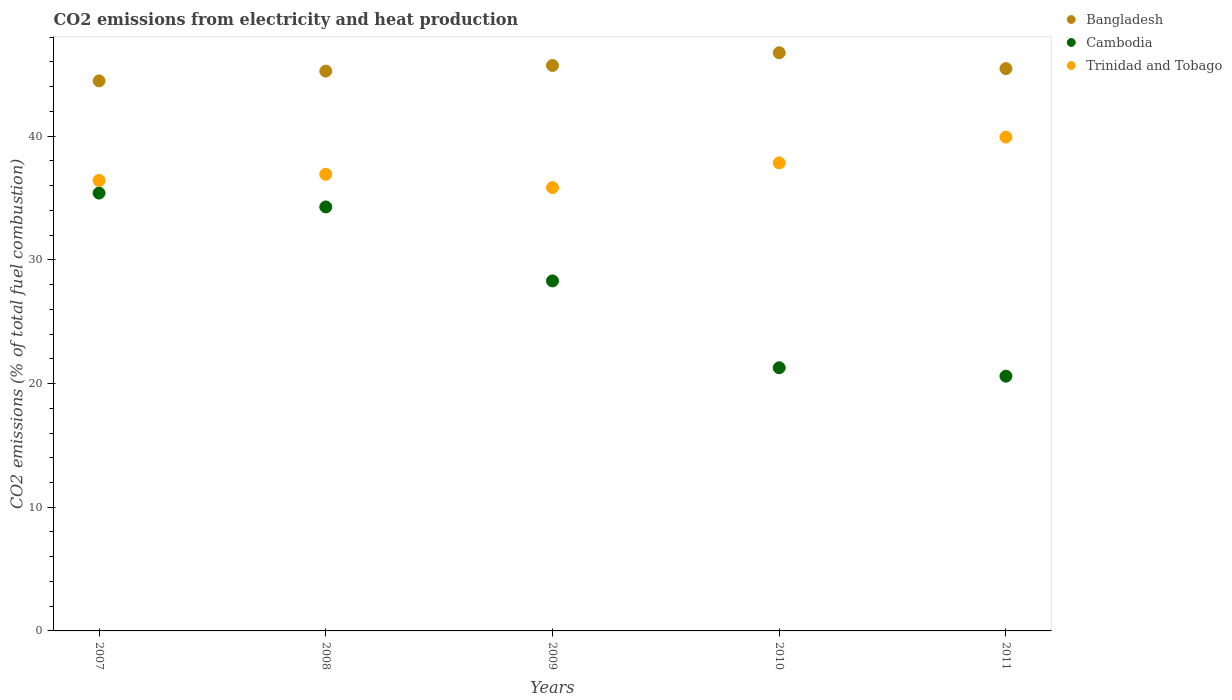What is the amount of CO2 emitted in Bangladesh in 2008?
Make the answer very short. 45.26. Across all years, what is the maximum amount of CO2 emitted in Bangladesh?
Provide a short and direct response. 46.74. Across all years, what is the minimum amount of CO2 emitted in Bangladesh?
Keep it short and to the point. 44.47. In which year was the amount of CO2 emitted in Bangladesh maximum?
Your answer should be very brief. 2010. In which year was the amount of CO2 emitted in Cambodia minimum?
Your answer should be compact. 2011. What is the total amount of CO2 emitted in Cambodia in the graph?
Your response must be concise. 139.84. What is the difference between the amount of CO2 emitted in Trinidad and Tobago in 2008 and that in 2011?
Your response must be concise. -3.01. What is the difference between the amount of CO2 emitted in Trinidad and Tobago in 2008 and the amount of CO2 emitted in Cambodia in 2009?
Ensure brevity in your answer.  8.62. What is the average amount of CO2 emitted in Trinidad and Tobago per year?
Keep it short and to the point. 37.39. In the year 2009, what is the difference between the amount of CO2 emitted in Bangladesh and amount of CO2 emitted in Trinidad and Tobago?
Provide a succinct answer. 9.87. In how many years, is the amount of CO2 emitted in Trinidad and Tobago greater than 12 %?
Your answer should be very brief. 5. What is the ratio of the amount of CO2 emitted in Bangladesh in 2008 to that in 2010?
Offer a terse response. 0.97. Is the difference between the amount of CO2 emitted in Bangladesh in 2007 and 2010 greater than the difference between the amount of CO2 emitted in Trinidad and Tobago in 2007 and 2010?
Make the answer very short. No. What is the difference between the highest and the second highest amount of CO2 emitted in Cambodia?
Offer a terse response. 1.12. What is the difference between the highest and the lowest amount of CO2 emitted in Cambodia?
Offer a terse response. 14.8. Is the sum of the amount of CO2 emitted in Trinidad and Tobago in 2008 and 2010 greater than the maximum amount of CO2 emitted in Bangladesh across all years?
Your response must be concise. Yes. Is the amount of CO2 emitted in Cambodia strictly greater than the amount of CO2 emitted in Bangladesh over the years?
Make the answer very short. No. Is the amount of CO2 emitted in Trinidad and Tobago strictly less than the amount of CO2 emitted in Cambodia over the years?
Make the answer very short. No. How many dotlines are there?
Your answer should be compact. 3. How many years are there in the graph?
Offer a very short reply. 5. Are the values on the major ticks of Y-axis written in scientific E-notation?
Give a very brief answer. No. Does the graph contain grids?
Ensure brevity in your answer.  No. Where does the legend appear in the graph?
Your response must be concise. Top right. What is the title of the graph?
Keep it short and to the point. CO2 emissions from electricity and heat production. Does "Seychelles" appear as one of the legend labels in the graph?
Keep it short and to the point. No. What is the label or title of the X-axis?
Your answer should be compact. Years. What is the label or title of the Y-axis?
Make the answer very short. CO2 emissions (% of total fuel combustion). What is the CO2 emissions (% of total fuel combustion) in Bangladesh in 2007?
Your answer should be very brief. 44.47. What is the CO2 emissions (% of total fuel combustion) of Cambodia in 2007?
Your answer should be very brief. 35.4. What is the CO2 emissions (% of total fuel combustion) of Trinidad and Tobago in 2007?
Provide a succinct answer. 36.42. What is the CO2 emissions (% of total fuel combustion) of Bangladesh in 2008?
Offer a very short reply. 45.26. What is the CO2 emissions (% of total fuel combustion) in Cambodia in 2008?
Make the answer very short. 34.28. What is the CO2 emissions (% of total fuel combustion) in Trinidad and Tobago in 2008?
Your response must be concise. 36.92. What is the CO2 emissions (% of total fuel combustion) of Bangladesh in 2009?
Provide a succinct answer. 45.71. What is the CO2 emissions (% of total fuel combustion) in Cambodia in 2009?
Your response must be concise. 28.3. What is the CO2 emissions (% of total fuel combustion) of Trinidad and Tobago in 2009?
Your response must be concise. 35.84. What is the CO2 emissions (% of total fuel combustion) in Bangladesh in 2010?
Your answer should be very brief. 46.74. What is the CO2 emissions (% of total fuel combustion) of Cambodia in 2010?
Ensure brevity in your answer.  21.28. What is the CO2 emissions (% of total fuel combustion) of Trinidad and Tobago in 2010?
Your response must be concise. 37.84. What is the CO2 emissions (% of total fuel combustion) in Bangladesh in 2011?
Offer a terse response. 45.46. What is the CO2 emissions (% of total fuel combustion) in Cambodia in 2011?
Provide a succinct answer. 20.6. What is the CO2 emissions (% of total fuel combustion) of Trinidad and Tobago in 2011?
Ensure brevity in your answer.  39.93. Across all years, what is the maximum CO2 emissions (% of total fuel combustion) of Bangladesh?
Make the answer very short. 46.74. Across all years, what is the maximum CO2 emissions (% of total fuel combustion) in Cambodia?
Offer a very short reply. 35.4. Across all years, what is the maximum CO2 emissions (% of total fuel combustion) of Trinidad and Tobago?
Your response must be concise. 39.93. Across all years, what is the minimum CO2 emissions (% of total fuel combustion) of Bangladesh?
Provide a succinct answer. 44.47. Across all years, what is the minimum CO2 emissions (% of total fuel combustion) in Cambodia?
Keep it short and to the point. 20.6. Across all years, what is the minimum CO2 emissions (% of total fuel combustion) of Trinidad and Tobago?
Keep it short and to the point. 35.84. What is the total CO2 emissions (% of total fuel combustion) of Bangladesh in the graph?
Make the answer very short. 227.65. What is the total CO2 emissions (% of total fuel combustion) of Cambodia in the graph?
Ensure brevity in your answer.  139.84. What is the total CO2 emissions (% of total fuel combustion) in Trinidad and Tobago in the graph?
Ensure brevity in your answer.  186.95. What is the difference between the CO2 emissions (% of total fuel combustion) of Bangladesh in 2007 and that in 2008?
Provide a short and direct response. -0.79. What is the difference between the CO2 emissions (% of total fuel combustion) of Cambodia in 2007 and that in 2008?
Your response must be concise. 1.12. What is the difference between the CO2 emissions (% of total fuel combustion) of Trinidad and Tobago in 2007 and that in 2008?
Keep it short and to the point. -0.5. What is the difference between the CO2 emissions (% of total fuel combustion) of Bangladesh in 2007 and that in 2009?
Your answer should be very brief. -1.24. What is the difference between the CO2 emissions (% of total fuel combustion) of Cambodia in 2007 and that in 2009?
Offer a terse response. 7.1. What is the difference between the CO2 emissions (% of total fuel combustion) in Trinidad and Tobago in 2007 and that in 2009?
Ensure brevity in your answer.  0.58. What is the difference between the CO2 emissions (% of total fuel combustion) in Bangladesh in 2007 and that in 2010?
Your response must be concise. -2.27. What is the difference between the CO2 emissions (% of total fuel combustion) in Cambodia in 2007 and that in 2010?
Your answer should be very brief. 14.12. What is the difference between the CO2 emissions (% of total fuel combustion) of Trinidad and Tobago in 2007 and that in 2010?
Provide a succinct answer. -1.42. What is the difference between the CO2 emissions (% of total fuel combustion) in Bangladesh in 2007 and that in 2011?
Provide a succinct answer. -0.99. What is the difference between the CO2 emissions (% of total fuel combustion) in Cambodia in 2007 and that in 2011?
Your answer should be very brief. 14.8. What is the difference between the CO2 emissions (% of total fuel combustion) of Trinidad and Tobago in 2007 and that in 2011?
Provide a succinct answer. -3.51. What is the difference between the CO2 emissions (% of total fuel combustion) of Bangladesh in 2008 and that in 2009?
Give a very brief answer. -0.46. What is the difference between the CO2 emissions (% of total fuel combustion) in Cambodia in 2008 and that in 2009?
Give a very brief answer. 5.98. What is the difference between the CO2 emissions (% of total fuel combustion) of Trinidad and Tobago in 2008 and that in 2009?
Your response must be concise. 1.07. What is the difference between the CO2 emissions (% of total fuel combustion) of Bangladesh in 2008 and that in 2010?
Provide a succinct answer. -1.48. What is the difference between the CO2 emissions (% of total fuel combustion) of Cambodia in 2008 and that in 2010?
Offer a terse response. 13. What is the difference between the CO2 emissions (% of total fuel combustion) of Trinidad and Tobago in 2008 and that in 2010?
Your answer should be very brief. -0.92. What is the difference between the CO2 emissions (% of total fuel combustion) in Bangladesh in 2008 and that in 2011?
Give a very brief answer. -0.2. What is the difference between the CO2 emissions (% of total fuel combustion) of Cambodia in 2008 and that in 2011?
Provide a short and direct response. 13.68. What is the difference between the CO2 emissions (% of total fuel combustion) of Trinidad and Tobago in 2008 and that in 2011?
Offer a terse response. -3.01. What is the difference between the CO2 emissions (% of total fuel combustion) of Bangladesh in 2009 and that in 2010?
Offer a terse response. -1.03. What is the difference between the CO2 emissions (% of total fuel combustion) of Cambodia in 2009 and that in 2010?
Your response must be concise. 7.02. What is the difference between the CO2 emissions (% of total fuel combustion) of Trinidad and Tobago in 2009 and that in 2010?
Ensure brevity in your answer.  -2. What is the difference between the CO2 emissions (% of total fuel combustion) of Bangladesh in 2009 and that in 2011?
Offer a terse response. 0.25. What is the difference between the CO2 emissions (% of total fuel combustion) of Cambodia in 2009 and that in 2011?
Make the answer very short. 7.7. What is the difference between the CO2 emissions (% of total fuel combustion) of Trinidad and Tobago in 2009 and that in 2011?
Your response must be concise. -4.08. What is the difference between the CO2 emissions (% of total fuel combustion) in Bangladesh in 2010 and that in 2011?
Provide a succinct answer. 1.28. What is the difference between the CO2 emissions (% of total fuel combustion) of Cambodia in 2010 and that in 2011?
Your answer should be very brief. 0.68. What is the difference between the CO2 emissions (% of total fuel combustion) of Trinidad and Tobago in 2010 and that in 2011?
Your response must be concise. -2.09. What is the difference between the CO2 emissions (% of total fuel combustion) in Bangladesh in 2007 and the CO2 emissions (% of total fuel combustion) in Cambodia in 2008?
Make the answer very short. 10.19. What is the difference between the CO2 emissions (% of total fuel combustion) of Bangladesh in 2007 and the CO2 emissions (% of total fuel combustion) of Trinidad and Tobago in 2008?
Your answer should be compact. 7.55. What is the difference between the CO2 emissions (% of total fuel combustion) in Cambodia in 2007 and the CO2 emissions (% of total fuel combustion) in Trinidad and Tobago in 2008?
Give a very brief answer. -1.52. What is the difference between the CO2 emissions (% of total fuel combustion) of Bangladesh in 2007 and the CO2 emissions (% of total fuel combustion) of Cambodia in 2009?
Ensure brevity in your answer.  16.17. What is the difference between the CO2 emissions (% of total fuel combustion) in Bangladesh in 2007 and the CO2 emissions (% of total fuel combustion) in Trinidad and Tobago in 2009?
Your answer should be compact. 8.63. What is the difference between the CO2 emissions (% of total fuel combustion) of Cambodia in 2007 and the CO2 emissions (% of total fuel combustion) of Trinidad and Tobago in 2009?
Your response must be concise. -0.45. What is the difference between the CO2 emissions (% of total fuel combustion) of Bangladesh in 2007 and the CO2 emissions (% of total fuel combustion) of Cambodia in 2010?
Keep it short and to the point. 23.19. What is the difference between the CO2 emissions (% of total fuel combustion) of Bangladesh in 2007 and the CO2 emissions (% of total fuel combustion) of Trinidad and Tobago in 2010?
Make the answer very short. 6.63. What is the difference between the CO2 emissions (% of total fuel combustion) in Cambodia in 2007 and the CO2 emissions (% of total fuel combustion) in Trinidad and Tobago in 2010?
Your answer should be very brief. -2.44. What is the difference between the CO2 emissions (% of total fuel combustion) in Bangladesh in 2007 and the CO2 emissions (% of total fuel combustion) in Cambodia in 2011?
Provide a short and direct response. 23.87. What is the difference between the CO2 emissions (% of total fuel combustion) of Bangladesh in 2007 and the CO2 emissions (% of total fuel combustion) of Trinidad and Tobago in 2011?
Provide a short and direct response. 4.54. What is the difference between the CO2 emissions (% of total fuel combustion) of Cambodia in 2007 and the CO2 emissions (% of total fuel combustion) of Trinidad and Tobago in 2011?
Give a very brief answer. -4.53. What is the difference between the CO2 emissions (% of total fuel combustion) of Bangladesh in 2008 and the CO2 emissions (% of total fuel combustion) of Cambodia in 2009?
Offer a very short reply. 16.96. What is the difference between the CO2 emissions (% of total fuel combustion) in Bangladesh in 2008 and the CO2 emissions (% of total fuel combustion) in Trinidad and Tobago in 2009?
Offer a terse response. 9.42. What is the difference between the CO2 emissions (% of total fuel combustion) in Cambodia in 2008 and the CO2 emissions (% of total fuel combustion) in Trinidad and Tobago in 2009?
Provide a short and direct response. -1.57. What is the difference between the CO2 emissions (% of total fuel combustion) of Bangladesh in 2008 and the CO2 emissions (% of total fuel combustion) of Cambodia in 2010?
Give a very brief answer. 23.98. What is the difference between the CO2 emissions (% of total fuel combustion) of Bangladesh in 2008 and the CO2 emissions (% of total fuel combustion) of Trinidad and Tobago in 2010?
Your response must be concise. 7.42. What is the difference between the CO2 emissions (% of total fuel combustion) of Cambodia in 2008 and the CO2 emissions (% of total fuel combustion) of Trinidad and Tobago in 2010?
Your answer should be very brief. -3.56. What is the difference between the CO2 emissions (% of total fuel combustion) in Bangladesh in 2008 and the CO2 emissions (% of total fuel combustion) in Cambodia in 2011?
Ensure brevity in your answer.  24.66. What is the difference between the CO2 emissions (% of total fuel combustion) of Bangladesh in 2008 and the CO2 emissions (% of total fuel combustion) of Trinidad and Tobago in 2011?
Give a very brief answer. 5.33. What is the difference between the CO2 emissions (% of total fuel combustion) in Cambodia in 2008 and the CO2 emissions (% of total fuel combustion) in Trinidad and Tobago in 2011?
Ensure brevity in your answer.  -5.65. What is the difference between the CO2 emissions (% of total fuel combustion) in Bangladesh in 2009 and the CO2 emissions (% of total fuel combustion) in Cambodia in 2010?
Your answer should be very brief. 24.44. What is the difference between the CO2 emissions (% of total fuel combustion) in Bangladesh in 2009 and the CO2 emissions (% of total fuel combustion) in Trinidad and Tobago in 2010?
Offer a very short reply. 7.88. What is the difference between the CO2 emissions (% of total fuel combustion) in Cambodia in 2009 and the CO2 emissions (% of total fuel combustion) in Trinidad and Tobago in 2010?
Give a very brief answer. -9.54. What is the difference between the CO2 emissions (% of total fuel combustion) in Bangladesh in 2009 and the CO2 emissions (% of total fuel combustion) in Cambodia in 2011?
Your answer should be very brief. 25.12. What is the difference between the CO2 emissions (% of total fuel combustion) in Bangladesh in 2009 and the CO2 emissions (% of total fuel combustion) in Trinidad and Tobago in 2011?
Your response must be concise. 5.79. What is the difference between the CO2 emissions (% of total fuel combustion) in Cambodia in 2009 and the CO2 emissions (% of total fuel combustion) in Trinidad and Tobago in 2011?
Provide a succinct answer. -11.63. What is the difference between the CO2 emissions (% of total fuel combustion) in Bangladesh in 2010 and the CO2 emissions (% of total fuel combustion) in Cambodia in 2011?
Offer a terse response. 26.15. What is the difference between the CO2 emissions (% of total fuel combustion) of Bangladesh in 2010 and the CO2 emissions (% of total fuel combustion) of Trinidad and Tobago in 2011?
Give a very brief answer. 6.82. What is the difference between the CO2 emissions (% of total fuel combustion) in Cambodia in 2010 and the CO2 emissions (% of total fuel combustion) in Trinidad and Tobago in 2011?
Provide a short and direct response. -18.65. What is the average CO2 emissions (% of total fuel combustion) in Bangladesh per year?
Make the answer very short. 45.53. What is the average CO2 emissions (% of total fuel combustion) in Cambodia per year?
Ensure brevity in your answer.  27.97. What is the average CO2 emissions (% of total fuel combustion) in Trinidad and Tobago per year?
Provide a short and direct response. 37.39. In the year 2007, what is the difference between the CO2 emissions (% of total fuel combustion) in Bangladesh and CO2 emissions (% of total fuel combustion) in Cambodia?
Your response must be concise. 9.07. In the year 2007, what is the difference between the CO2 emissions (% of total fuel combustion) in Bangladesh and CO2 emissions (% of total fuel combustion) in Trinidad and Tobago?
Give a very brief answer. 8.05. In the year 2007, what is the difference between the CO2 emissions (% of total fuel combustion) of Cambodia and CO2 emissions (% of total fuel combustion) of Trinidad and Tobago?
Provide a succinct answer. -1.02. In the year 2008, what is the difference between the CO2 emissions (% of total fuel combustion) of Bangladesh and CO2 emissions (% of total fuel combustion) of Cambodia?
Keep it short and to the point. 10.98. In the year 2008, what is the difference between the CO2 emissions (% of total fuel combustion) of Bangladesh and CO2 emissions (% of total fuel combustion) of Trinidad and Tobago?
Give a very brief answer. 8.34. In the year 2008, what is the difference between the CO2 emissions (% of total fuel combustion) of Cambodia and CO2 emissions (% of total fuel combustion) of Trinidad and Tobago?
Ensure brevity in your answer.  -2.64. In the year 2009, what is the difference between the CO2 emissions (% of total fuel combustion) in Bangladesh and CO2 emissions (% of total fuel combustion) in Cambodia?
Your response must be concise. 17.42. In the year 2009, what is the difference between the CO2 emissions (% of total fuel combustion) of Bangladesh and CO2 emissions (% of total fuel combustion) of Trinidad and Tobago?
Make the answer very short. 9.87. In the year 2009, what is the difference between the CO2 emissions (% of total fuel combustion) in Cambodia and CO2 emissions (% of total fuel combustion) in Trinidad and Tobago?
Make the answer very short. -7.55. In the year 2010, what is the difference between the CO2 emissions (% of total fuel combustion) in Bangladesh and CO2 emissions (% of total fuel combustion) in Cambodia?
Give a very brief answer. 25.47. In the year 2010, what is the difference between the CO2 emissions (% of total fuel combustion) in Bangladesh and CO2 emissions (% of total fuel combustion) in Trinidad and Tobago?
Provide a short and direct response. 8.9. In the year 2010, what is the difference between the CO2 emissions (% of total fuel combustion) of Cambodia and CO2 emissions (% of total fuel combustion) of Trinidad and Tobago?
Provide a succinct answer. -16.56. In the year 2011, what is the difference between the CO2 emissions (% of total fuel combustion) in Bangladesh and CO2 emissions (% of total fuel combustion) in Cambodia?
Provide a short and direct response. 24.87. In the year 2011, what is the difference between the CO2 emissions (% of total fuel combustion) in Bangladesh and CO2 emissions (% of total fuel combustion) in Trinidad and Tobago?
Offer a terse response. 5.53. In the year 2011, what is the difference between the CO2 emissions (% of total fuel combustion) of Cambodia and CO2 emissions (% of total fuel combustion) of Trinidad and Tobago?
Provide a short and direct response. -19.33. What is the ratio of the CO2 emissions (% of total fuel combustion) in Bangladesh in 2007 to that in 2008?
Provide a succinct answer. 0.98. What is the ratio of the CO2 emissions (% of total fuel combustion) of Cambodia in 2007 to that in 2008?
Ensure brevity in your answer.  1.03. What is the ratio of the CO2 emissions (% of total fuel combustion) of Trinidad and Tobago in 2007 to that in 2008?
Your answer should be very brief. 0.99. What is the ratio of the CO2 emissions (% of total fuel combustion) in Bangladesh in 2007 to that in 2009?
Offer a terse response. 0.97. What is the ratio of the CO2 emissions (% of total fuel combustion) in Cambodia in 2007 to that in 2009?
Ensure brevity in your answer.  1.25. What is the ratio of the CO2 emissions (% of total fuel combustion) in Trinidad and Tobago in 2007 to that in 2009?
Ensure brevity in your answer.  1.02. What is the ratio of the CO2 emissions (% of total fuel combustion) of Bangladesh in 2007 to that in 2010?
Your answer should be very brief. 0.95. What is the ratio of the CO2 emissions (% of total fuel combustion) of Cambodia in 2007 to that in 2010?
Your response must be concise. 1.66. What is the ratio of the CO2 emissions (% of total fuel combustion) of Trinidad and Tobago in 2007 to that in 2010?
Your response must be concise. 0.96. What is the ratio of the CO2 emissions (% of total fuel combustion) of Bangladesh in 2007 to that in 2011?
Offer a very short reply. 0.98. What is the ratio of the CO2 emissions (% of total fuel combustion) of Cambodia in 2007 to that in 2011?
Your answer should be compact. 1.72. What is the ratio of the CO2 emissions (% of total fuel combustion) of Trinidad and Tobago in 2007 to that in 2011?
Provide a succinct answer. 0.91. What is the ratio of the CO2 emissions (% of total fuel combustion) in Cambodia in 2008 to that in 2009?
Make the answer very short. 1.21. What is the ratio of the CO2 emissions (% of total fuel combustion) of Bangladesh in 2008 to that in 2010?
Ensure brevity in your answer.  0.97. What is the ratio of the CO2 emissions (% of total fuel combustion) of Cambodia in 2008 to that in 2010?
Provide a succinct answer. 1.61. What is the ratio of the CO2 emissions (% of total fuel combustion) of Trinidad and Tobago in 2008 to that in 2010?
Your answer should be very brief. 0.98. What is the ratio of the CO2 emissions (% of total fuel combustion) of Cambodia in 2008 to that in 2011?
Provide a short and direct response. 1.66. What is the ratio of the CO2 emissions (% of total fuel combustion) in Trinidad and Tobago in 2008 to that in 2011?
Ensure brevity in your answer.  0.92. What is the ratio of the CO2 emissions (% of total fuel combustion) in Cambodia in 2009 to that in 2010?
Your response must be concise. 1.33. What is the ratio of the CO2 emissions (% of total fuel combustion) in Trinidad and Tobago in 2009 to that in 2010?
Your answer should be very brief. 0.95. What is the ratio of the CO2 emissions (% of total fuel combustion) in Bangladesh in 2009 to that in 2011?
Provide a short and direct response. 1.01. What is the ratio of the CO2 emissions (% of total fuel combustion) of Cambodia in 2009 to that in 2011?
Provide a succinct answer. 1.37. What is the ratio of the CO2 emissions (% of total fuel combustion) in Trinidad and Tobago in 2009 to that in 2011?
Provide a succinct answer. 0.9. What is the ratio of the CO2 emissions (% of total fuel combustion) of Bangladesh in 2010 to that in 2011?
Your answer should be very brief. 1.03. What is the ratio of the CO2 emissions (% of total fuel combustion) of Cambodia in 2010 to that in 2011?
Your answer should be compact. 1.03. What is the ratio of the CO2 emissions (% of total fuel combustion) of Trinidad and Tobago in 2010 to that in 2011?
Give a very brief answer. 0.95. What is the difference between the highest and the second highest CO2 emissions (% of total fuel combustion) of Bangladesh?
Offer a very short reply. 1.03. What is the difference between the highest and the second highest CO2 emissions (% of total fuel combustion) of Cambodia?
Offer a terse response. 1.12. What is the difference between the highest and the second highest CO2 emissions (% of total fuel combustion) of Trinidad and Tobago?
Provide a short and direct response. 2.09. What is the difference between the highest and the lowest CO2 emissions (% of total fuel combustion) of Bangladesh?
Your answer should be very brief. 2.27. What is the difference between the highest and the lowest CO2 emissions (% of total fuel combustion) of Cambodia?
Your answer should be very brief. 14.8. What is the difference between the highest and the lowest CO2 emissions (% of total fuel combustion) of Trinidad and Tobago?
Keep it short and to the point. 4.08. 